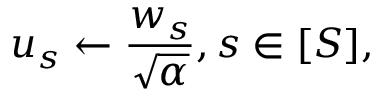<formula> <loc_0><loc_0><loc_500><loc_500>u _ { s } \gets \frac { w _ { s } } { \sqrt { \alpha } } , s \in [ S ] ,</formula> 